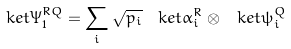<formula> <loc_0><loc_0><loc_500><loc_500>\ k e t { \Psi ^ { R Q } _ { 1 } } = \sum _ { i } \sqrt { p _ { i } } \, \ k e t { \alpha ^ { R } _ { i } } \otimes \ k e t { \psi ^ { Q } _ { i } }</formula> 